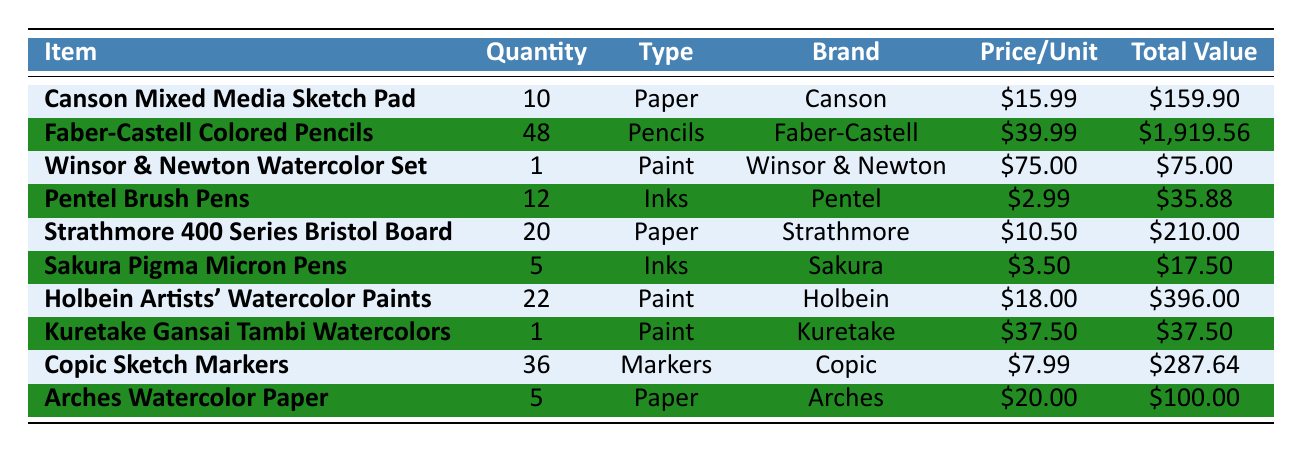What is the total quantity of Faber-Castell Colored Pencils? The table shows that the quantity for Faber-Castell Colored Pencils is listed as 48.
Answer: 48 Which item has the highest total value in the inventory? By comparing the total values, Faber-Castell Colored Pencils have a total value of $1,919.56, which is higher than any other item.
Answer: Faber-Castell Colored Pencils What type of art supply is the Winsor & Newton Watercolor Set? The table indicates that Winsor & Newton Watercolor Set is classified under the type "Paint."
Answer: Paint How many more units of Strathmore 400 Series Bristol Board are there than Sakura Pigma Micron Pens? Strathmore 400 Series Bristol Board has 20 units, while Sakura Pigma Micron Pens have 5 units. The difference is 20 - 5 = 15.
Answer: 15 What is the total value of all the paints listed? The total value of the paints includes Winsor & Newton Watercolor Set ($75.00), Holbein Artists' Watercolor Paints ($396.00), and Kuretake Gansai Tambi Watercolors ($37.50). Adding these gives $75.00 + $396.00 + $37.50 = $508.50.
Answer: $508.50 Are there more types of Inks or Papers listed in the inventory? There are 4 items classified as Paper (Canson Mixed Media Sketch Pad, Strathmore 400 Series Bristol Board, Holbein Artists' Watercolor Paper, Arches Watercolor Paper) and 2 items classified as Inks (Pentel Brush Pens, Sakura Pigma Micron Pens). Thus, there are more types of Paper.
Answer: Yes What is the average price per unit of all the art supplies? The total prices per unit are added up: $15.99 + $39.99 + $75.00 + $2.99 + $10.50 + $3.50 + $18.00 + $37.50 + $7.99 + $20.00 = $312.46. There are 10 items, so the average price is $312.46 / 10 = $31.25.
Answer: $31.25 How many units of Pentel Brush Pens and Sakura Pigma Micron Pens combined do you have? The quantity of Pentel Brush Pens is 12, and Sakura Pigma Micron Pens is 5. Adding these gives 12 + 5 = 17.
Answer: 17 What is the total value for the Copic Sketch Markers? The table indicates that the total value for Copic Sketch Markers is listed as $287.64.
Answer: $287.64 Is it true that all the art supplies listed are from different brands? By reviewing the brands, we notice that both Faber-Castell and Copic are present. Therefore, this statement is false.
Answer: No 